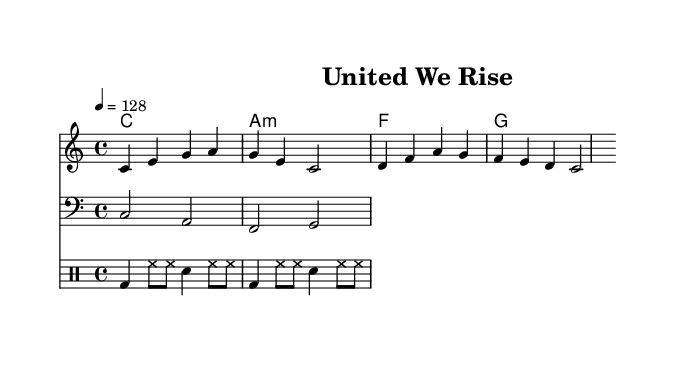What is the key signature of this music? The key signature is C major, which has no sharps or flats.
Answer: C major What is the time signature of the piece? The time signature is shown at the beginning of the sheet music, indicating that there are four beats in a measure.
Answer: 4/4 What is the tempo marking for the music? The tempo marking is indicated in beats per minute, showing that the tempo is set to 128 beats per minute.
Answer: 128 What type of drum patterns are used in this piece? The drum patterns consist of bass drum and hi-hat patterns combined with snare hits, typical of electronic dance music.
Answer: Electronic dance What is the first lyric line of the song? The first line of lyrics is visible directly beneath the melody, starting with "United we stand".
Answer: United we stand How many measures does the melody consist of? By counting the distinct measure markings, we can see there are four measures present in the melody.
Answer: 4 What chord follows the first measure of the bassline? The first measure of the bassline shows a C note, which is the root note indicating the chord.
Answer: C 